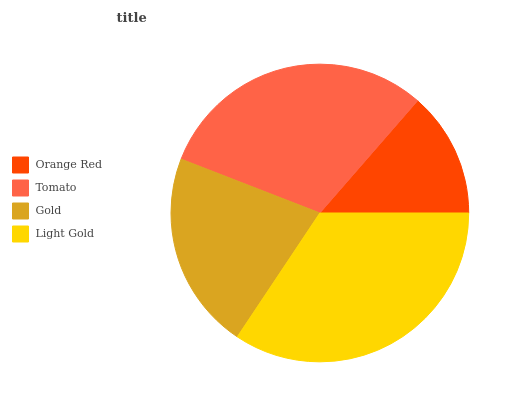Is Orange Red the minimum?
Answer yes or no. Yes. Is Light Gold the maximum?
Answer yes or no. Yes. Is Tomato the minimum?
Answer yes or no. No. Is Tomato the maximum?
Answer yes or no. No. Is Tomato greater than Orange Red?
Answer yes or no. Yes. Is Orange Red less than Tomato?
Answer yes or no. Yes. Is Orange Red greater than Tomato?
Answer yes or no. No. Is Tomato less than Orange Red?
Answer yes or no. No. Is Tomato the high median?
Answer yes or no. Yes. Is Gold the low median?
Answer yes or no. Yes. Is Gold the high median?
Answer yes or no. No. Is Light Gold the low median?
Answer yes or no. No. 